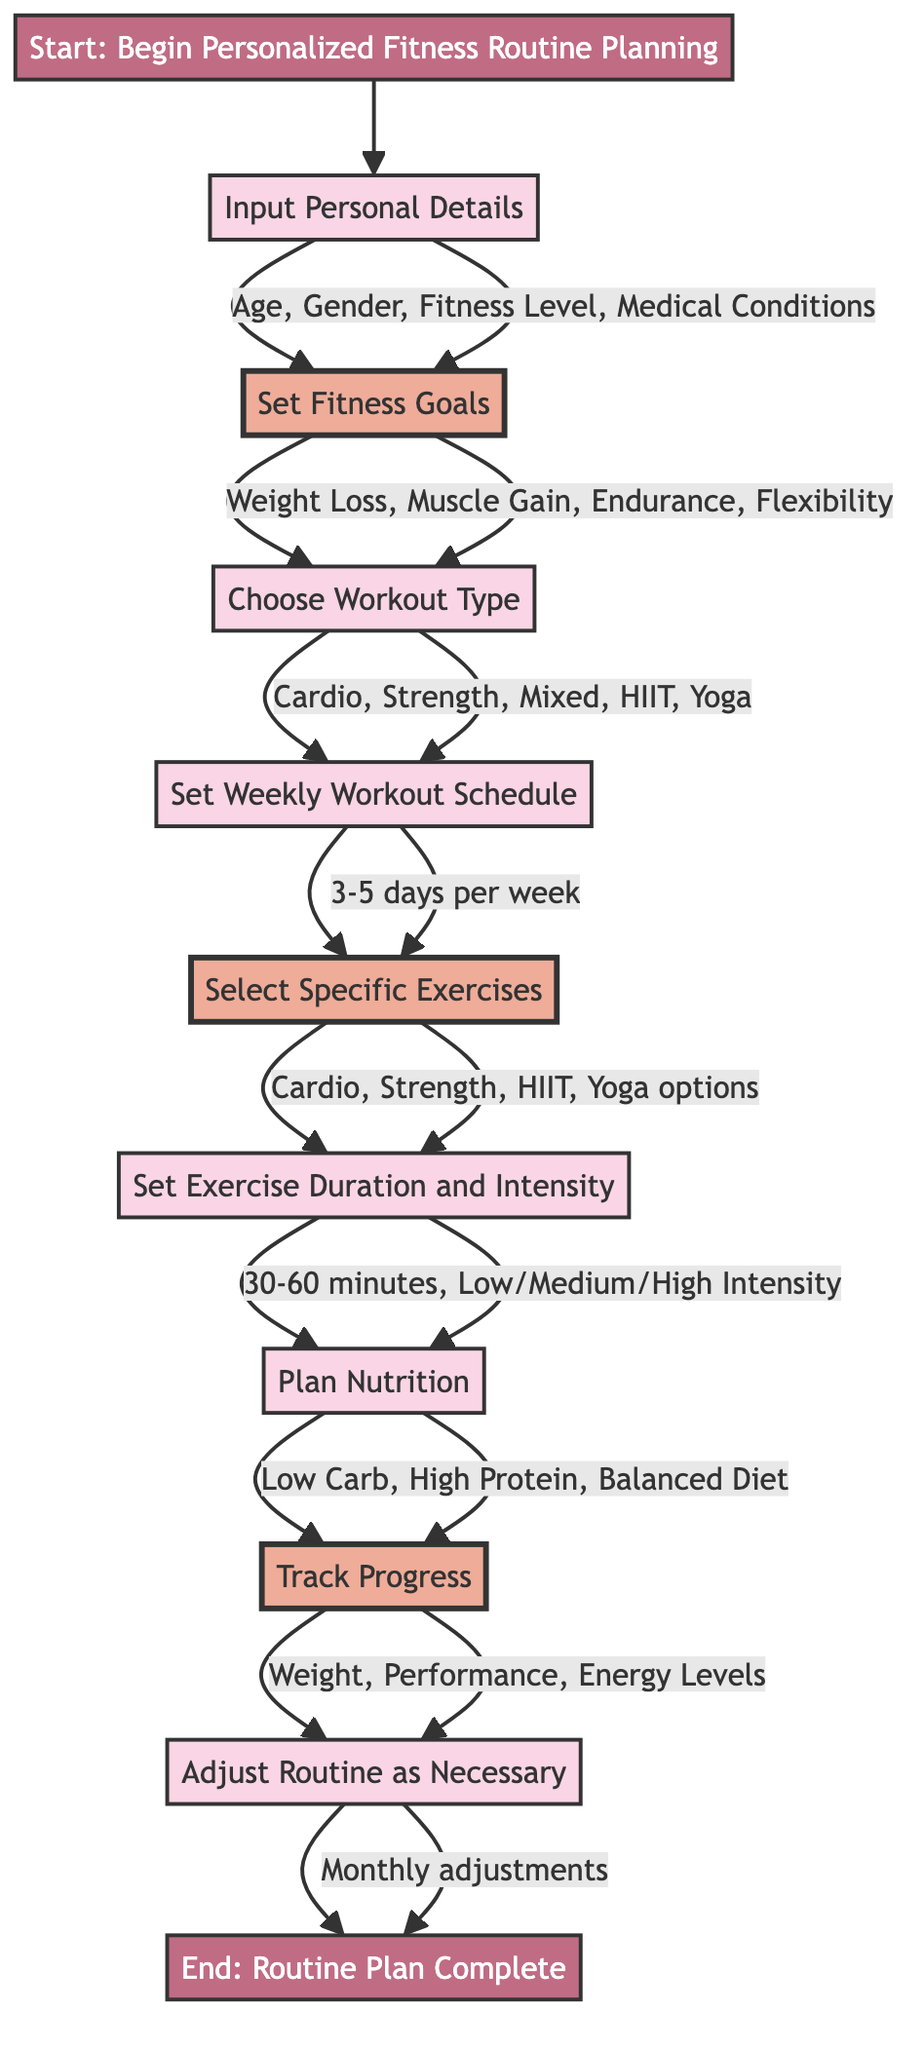What is the first step in the flowchart? The first step is labeled as "Start" and indicates "Begin Personalized Fitness Routine Planning."
Answer: Begin Personalized Fitness Routine Planning What details does the user need to input? The user is required to input "Age," "Gender," "Current Fitness Level," and "Medical Conditions."
Answer: Age, Gender, Current Fitness Level, Medical Conditions How many workout days are suggested per week? The flowchart recommends setting a workout schedule of "3-5 days" per week.
Answer: 3-5 days What types of goals can the user set? The user can select from the following goal types: "Weight Loss," "Muscle Gain," "Endurance," and "Flexibility."
Answer: Weight Loss, Muscle Gain, Endurance, Flexibility What is the last step in the flowchart? The last step is marked as "End" and states "Routine Plan Complete."
Answer: Routine Plan Complete What are the intensity levels described in the flowchart? The intensity levels available for exercise are "Low," "Medium," and "High."
Answer: Low, Medium, High What factors are considered for adjusting the routine? The adjustment factors include "Plateaus," "Goal Changes," and "New Preferences."
Answer: Plateaus, Goal Changes, New Preferences How often is progress tracked according to the flowchart? The flowchart specifies that progress should be tracked "Weekly."
Answer: Weekly What type of diet options can be planned? The diet options available are "Low Carb," "High Protein," and "Balanced Diet."
Answer: Low Carb, High Protein, Balanced Diet 